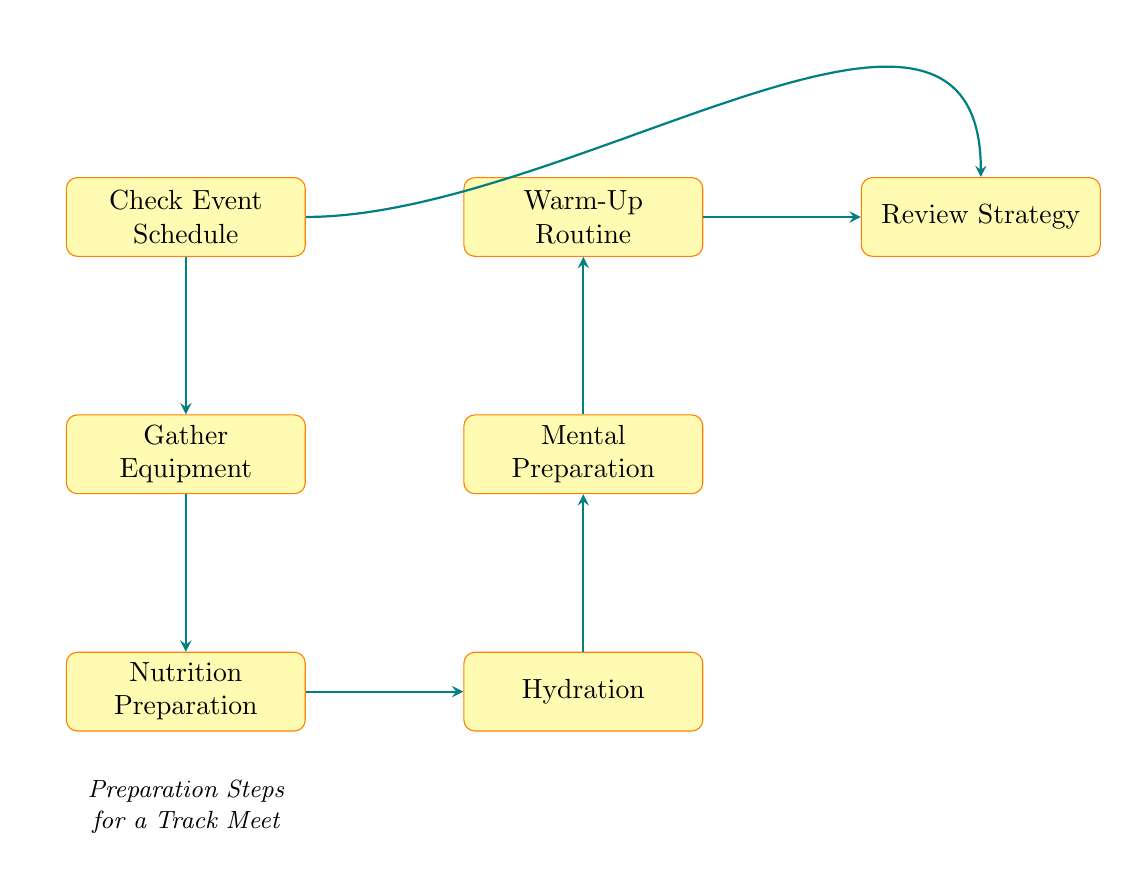What is the first step in the preparation process? The diagram starts with the node labeled "Check Event Schedule", which is the initial step in the flow of preparation.
Answer: Check Event Schedule How many nodes are in the preparation steps? By counting the nodes in the diagram, there are a total of seven distinct steps represented.
Answer: 7 What is the last step before reviewing the strategy? The node immediately before "Review Strategy" is "Warm-Up Routine", which is the last preparation step before strategizing.
Answer: Warm-Up Routine What are the two steps that come after nutrition preparation? Following "Nutrition Preparation", the next step is "Hydration", and after that is "Mental Preparation", making them the two subsequent steps.
Answer: Hydration, Mental Preparation Which preparation step involves mental activities? The step that focuses on mental activities is labeled "Mental Preparation", as it mentions visualization and motivation.
Answer: Mental Preparation If you skip hydration, what step do you move on to next? If "Hydration" is skipped, the next step would be "Mental Preparation", as it is directly downstream from hydration in the flowchart.
Answer: Mental Preparation Is there a step that can be considered a comprehensive fitness strategy review? "Review Strategy" serves as the comprehensive fitness strategy review, as it covers race-related tactics like pacing and techniques.
Answer: Review Strategy Which two steps are primarily focused on physical readiness? The steps that are centered on physical readiness are "Warm-Up Routine" and "Gather Equipment", as they are essential for preparing physically for the meet.
Answer: Warm-Up Routine, Gather Equipment What is the key focus of the nutrition preparation step? The "Nutrition Preparation" step emphasizes planning meals and snacks to ensure an athlete's proper nutrition before the meet.
Answer: Plan meals and snacks 